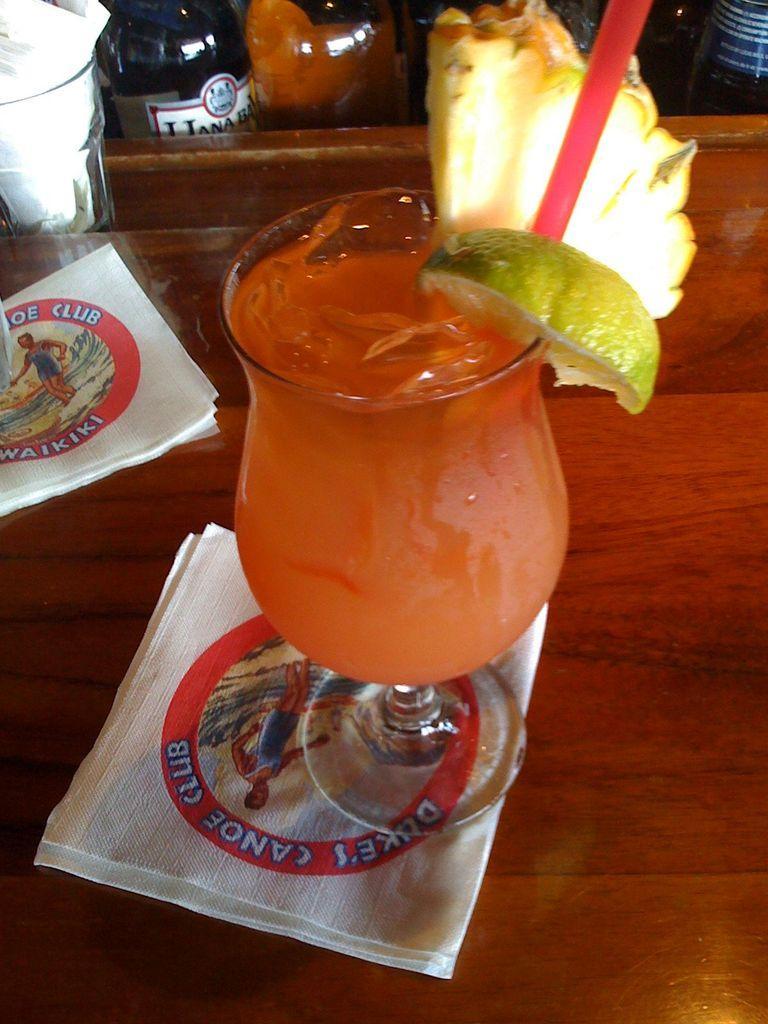Describe this image in one or two sentences. In this picture we can see a table, there is a glass of drink and tissue papers on the table, we can see a straw, a piece if lemon and a piece of a fruit in the middle, there are bottles and a glass at the left top of the picture. 